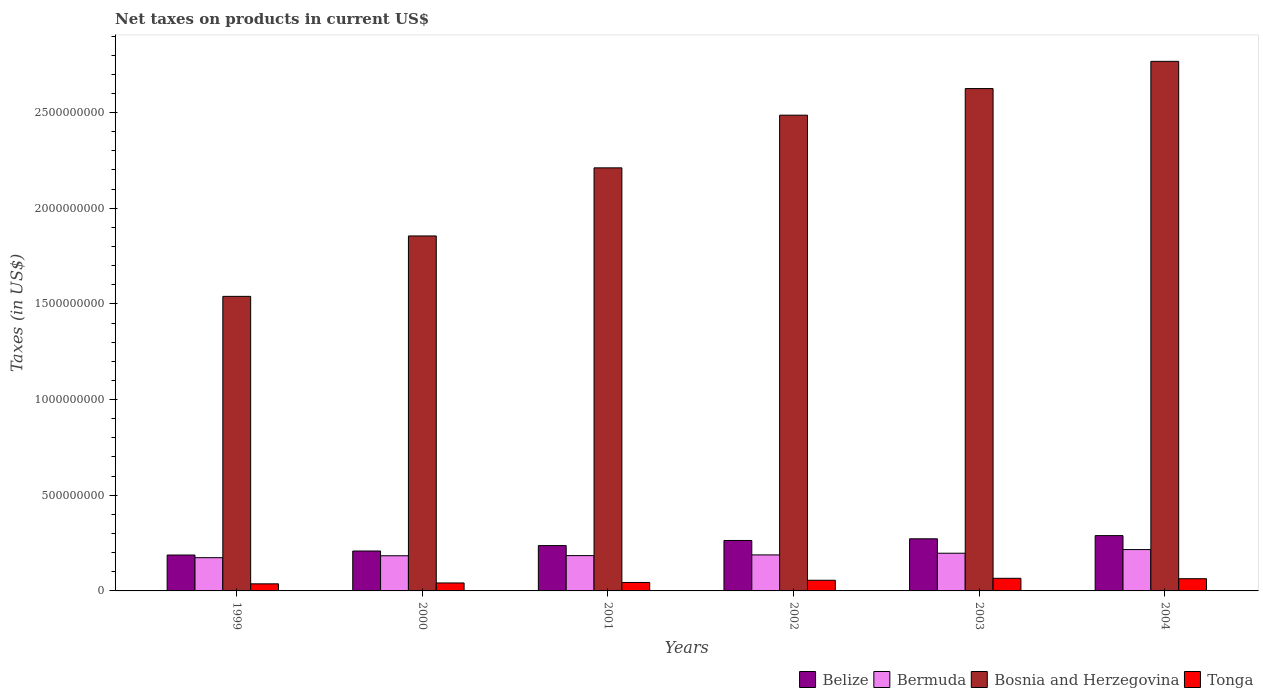How many different coloured bars are there?
Offer a very short reply. 4. How many bars are there on the 4th tick from the left?
Keep it short and to the point. 4. What is the label of the 6th group of bars from the left?
Provide a succinct answer. 2004. What is the net taxes on products in Tonga in 1999?
Keep it short and to the point. 3.70e+07. Across all years, what is the maximum net taxes on products in Bermuda?
Your answer should be compact. 2.16e+08. Across all years, what is the minimum net taxes on products in Bosnia and Herzegovina?
Offer a very short reply. 1.54e+09. In which year was the net taxes on products in Tonga maximum?
Offer a very short reply. 2003. What is the total net taxes on products in Belize in the graph?
Keep it short and to the point. 1.46e+09. What is the difference between the net taxes on products in Tonga in 2003 and that in 2004?
Keep it short and to the point. 2.12e+06. What is the difference between the net taxes on products in Bosnia and Herzegovina in 2000 and the net taxes on products in Tonga in 2004?
Make the answer very short. 1.79e+09. What is the average net taxes on products in Belize per year?
Offer a terse response. 2.43e+08. In the year 2000, what is the difference between the net taxes on products in Bosnia and Herzegovina and net taxes on products in Bermuda?
Your answer should be very brief. 1.67e+09. In how many years, is the net taxes on products in Bermuda greater than 700000000 US$?
Your answer should be very brief. 0. What is the ratio of the net taxes on products in Belize in 2001 to that in 2002?
Your answer should be compact. 0.9. Is the difference between the net taxes on products in Bosnia and Herzegovina in 2000 and 2004 greater than the difference between the net taxes on products in Bermuda in 2000 and 2004?
Keep it short and to the point. No. What is the difference between the highest and the second highest net taxes on products in Tonga?
Ensure brevity in your answer.  2.12e+06. What is the difference between the highest and the lowest net taxes on products in Bermuda?
Offer a terse response. 4.24e+07. Is it the case that in every year, the sum of the net taxes on products in Tonga and net taxes on products in Bosnia and Herzegovina is greater than the sum of net taxes on products in Belize and net taxes on products in Bermuda?
Your answer should be very brief. Yes. What does the 2nd bar from the left in 1999 represents?
Keep it short and to the point. Bermuda. What does the 3rd bar from the right in 1999 represents?
Provide a succinct answer. Bermuda. Is it the case that in every year, the sum of the net taxes on products in Bosnia and Herzegovina and net taxes on products in Belize is greater than the net taxes on products in Tonga?
Your response must be concise. Yes. How many years are there in the graph?
Keep it short and to the point. 6. Does the graph contain any zero values?
Provide a short and direct response. No. Where does the legend appear in the graph?
Give a very brief answer. Bottom right. How are the legend labels stacked?
Offer a very short reply. Horizontal. What is the title of the graph?
Your answer should be very brief. Net taxes on products in current US$. Does "Angola" appear as one of the legend labels in the graph?
Make the answer very short. No. What is the label or title of the Y-axis?
Your answer should be compact. Taxes (in US$). What is the Taxes (in US$) of Belize in 1999?
Ensure brevity in your answer.  1.88e+08. What is the Taxes (in US$) of Bermuda in 1999?
Provide a succinct answer. 1.74e+08. What is the Taxes (in US$) in Bosnia and Herzegovina in 1999?
Offer a terse response. 1.54e+09. What is the Taxes (in US$) in Tonga in 1999?
Keep it short and to the point. 3.70e+07. What is the Taxes (in US$) in Belize in 2000?
Provide a succinct answer. 2.09e+08. What is the Taxes (in US$) in Bermuda in 2000?
Your answer should be very brief. 1.84e+08. What is the Taxes (in US$) in Bosnia and Herzegovina in 2000?
Provide a succinct answer. 1.86e+09. What is the Taxes (in US$) of Tonga in 2000?
Give a very brief answer. 4.16e+07. What is the Taxes (in US$) of Belize in 2001?
Ensure brevity in your answer.  2.37e+08. What is the Taxes (in US$) in Bermuda in 2001?
Keep it short and to the point. 1.85e+08. What is the Taxes (in US$) of Bosnia and Herzegovina in 2001?
Offer a terse response. 2.21e+09. What is the Taxes (in US$) in Tonga in 2001?
Provide a short and direct response. 4.42e+07. What is the Taxes (in US$) of Belize in 2002?
Your response must be concise. 2.64e+08. What is the Taxes (in US$) in Bermuda in 2002?
Your response must be concise. 1.88e+08. What is the Taxes (in US$) in Bosnia and Herzegovina in 2002?
Keep it short and to the point. 2.49e+09. What is the Taxes (in US$) in Tonga in 2002?
Make the answer very short. 5.57e+07. What is the Taxes (in US$) in Belize in 2003?
Provide a short and direct response. 2.72e+08. What is the Taxes (in US$) of Bermuda in 2003?
Your response must be concise. 1.97e+08. What is the Taxes (in US$) in Bosnia and Herzegovina in 2003?
Offer a terse response. 2.63e+09. What is the Taxes (in US$) in Tonga in 2003?
Make the answer very short. 6.59e+07. What is the Taxes (in US$) in Belize in 2004?
Make the answer very short. 2.89e+08. What is the Taxes (in US$) in Bermuda in 2004?
Your response must be concise. 2.16e+08. What is the Taxes (in US$) in Bosnia and Herzegovina in 2004?
Offer a terse response. 2.77e+09. What is the Taxes (in US$) of Tonga in 2004?
Make the answer very short. 6.38e+07. Across all years, what is the maximum Taxes (in US$) in Belize?
Offer a very short reply. 2.89e+08. Across all years, what is the maximum Taxes (in US$) of Bermuda?
Your response must be concise. 2.16e+08. Across all years, what is the maximum Taxes (in US$) of Bosnia and Herzegovina?
Offer a terse response. 2.77e+09. Across all years, what is the maximum Taxes (in US$) of Tonga?
Offer a terse response. 6.59e+07. Across all years, what is the minimum Taxes (in US$) of Belize?
Ensure brevity in your answer.  1.88e+08. Across all years, what is the minimum Taxes (in US$) in Bermuda?
Your response must be concise. 1.74e+08. Across all years, what is the minimum Taxes (in US$) in Bosnia and Herzegovina?
Offer a terse response. 1.54e+09. Across all years, what is the minimum Taxes (in US$) of Tonga?
Give a very brief answer. 3.70e+07. What is the total Taxes (in US$) in Belize in the graph?
Make the answer very short. 1.46e+09. What is the total Taxes (in US$) in Bermuda in the graph?
Offer a terse response. 1.14e+09. What is the total Taxes (in US$) of Bosnia and Herzegovina in the graph?
Provide a succinct answer. 1.35e+1. What is the total Taxes (in US$) of Tonga in the graph?
Give a very brief answer. 3.08e+08. What is the difference between the Taxes (in US$) of Belize in 1999 and that in 2000?
Keep it short and to the point. -2.09e+07. What is the difference between the Taxes (in US$) of Bermuda in 1999 and that in 2000?
Your answer should be compact. -1.01e+07. What is the difference between the Taxes (in US$) in Bosnia and Herzegovina in 1999 and that in 2000?
Provide a short and direct response. -3.16e+08. What is the difference between the Taxes (in US$) in Tonga in 1999 and that in 2000?
Your answer should be very brief. -4.54e+06. What is the difference between the Taxes (in US$) of Belize in 1999 and that in 2001?
Provide a short and direct response. -4.93e+07. What is the difference between the Taxes (in US$) of Bermuda in 1999 and that in 2001?
Provide a short and direct response. -1.09e+07. What is the difference between the Taxes (in US$) in Bosnia and Herzegovina in 1999 and that in 2001?
Make the answer very short. -6.72e+08. What is the difference between the Taxes (in US$) of Tonga in 1999 and that in 2001?
Provide a short and direct response. -7.20e+06. What is the difference between the Taxes (in US$) in Belize in 1999 and that in 2002?
Your response must be concise. -7.60e+07. What is the difference between the Taxes (in US$) of Bermuda in 1999 and that in 2002?
Provide a succinct answer. -1.46e+07. What is the difference between the Taxes (in US$) of Bosnia and Herzegovina in 1999 and that in 2002?
Your response must be concise. -9.47e+08. What is the difference between the Taxes (in US$) in Tonga in 1999 and that in 2002?
Make the answer very short. -1.87e+07. What is the difference between the Taxes (in US$) of Belize in 1999 and that in 2003?
Your response must be concise. -8.48e+07. What is the difference between the Taxes (in US$) in Bermuda in 1999 and that in 2003?
Offer a very short reply. -2.33e+07. What is the difference between the Taxes (in US$) in Bosnia and Herzegovina in 1999 and that in 2003?
Keep it short and to the point. -1.09e+09. What is the difference between the Taxes (in US$) in Tonga in 1999 and that in 2003?
Give a very brief answer. -2.89e+07. What is the difference between the Taxes (in US$) of Belize in 1999 and that in 2004?
Offer a terse response. -1.01e+08. What is the difference between the Taxes (in US$) in Bermuda in 1999 and that in 2004?
Offer a terse response. -4.24e+07. What is the difference between the Taxes (in US$) in Bosnia and Herzegovina in 1999 and that in 2004?
Offer a very short reply. -1.23e+09. What is the difference between the Taxes (in US$) of Tonga in 1999 and that in 2004?
Your answer should be compact. -2.68e+07. What is the difference between the Taxes (in US$) of Belize in 2000 and that in 2001?
Your response must be concise. -2.83e+07. What is the difference between the Taxes (in US$) of Bermuda in 2000 and that in 2001?
Provide a short and direct response. -8.67e+05. What is the difference between the Taxes (in US$) of Bosnia and Herzegovina in 2000 and that in 2001?
Ensure brevity in your answer.  -3.56e+08. What is the difference between the Taxes (in US$) in Tonga in 2000 and that in 2001?
Ensure brevity in your answer.  -2.67e+06. What is the difference between the Taxes (in US$) in Belize in 2000 and that in 2002?
Offer a very short reply. -5.51e+07. What is the difference between the Taxes (in US$) in Bermuda in 2000 and that in 2002?
Your answer should be very brief. -4.49e+06. What is the difference between the Taxes (in US$) in Bosnia and Herzegovina in 2000 and that in 2002?
Provide a succinct answer. -6.31e+08. What is the difference between the Taxes (in US$) in Tonga in 2000 and that in 2002?
Make the answer very short. -1.42e+07. What is the difference between the Taxes (in US$) of Belize in 2000 and that in 2003?
Provide a short and direct response. -6.38e+07. What is the difference between the Taxes (in US$) of Bermuda in 2000 and that in 2003?
Your answer should be very brief. -1.32e+07. What is the difference between the Taxes (in US$) in Bosnia and Herzegovina in 2000 and that in 2003?
Provide a short and direct response. -7.70e+08. What is the difference between the Taxes (in US$) of Tonga in 2000 and that in 2003?
Your answer should be very brief. -2.43e+07. What is the difference between the Taxes (in US$) in Belize in 2000 and that in 2004?
Your response must be concise. -8.04e+07. What is the difference between the Taxes (in US$) of Bermuda in 2000 and that in 2004?
Your answer should be compact. -3.23e+07. What is the difference between the Taxes (in US$) of Bosnia and Herzegovina in 2000 and that in 2004?
Make the answer very short. -9.12e+08. What is the difference between the Taxes (in US$) in Tonga in 2000 and that in 2004?
Your answer should be very brief. -2.22e+07. What is the difference between the Taxes (in US$) of Belize in 2001 and that in 2002?
Provide a short and direct response. -2.67e+07. What is the difference between the Taxes (in US$) in Bermuda in 2001 and that in 2002?
Keep it short and to the point. -3.62e+06. What is the difference between the Taxes (in US$) of Bosnia and Herzegovina in 2001 and that in 2002?
Provide a succinct answer. -2.75e+08. What is the difference between the Taxes (in US$) in Tonga in 2001 and that in 2002?
Offer a very short reply. -1.15e+07. What is the difference between the Taxes (in US$) in Belize in 2001 and that in 2003?
Provide a succinct answer. -3.55e+07. What is the difference between the Taxes (in US$) in Bermuda in 2001 and that in 2003?
Give a very brief answer. -1.24e+07. What is the difference between the Taxes (in US$) in Bosnia and Herzegovina in 2001 and that in 2003?
Your response must be concise. -4.14e+08. What is the difference between the Taxes (in US$) of Tonga in 2001 and that in 2003?
Ensure brevity in your answer.  -2.17e+07. What is the difference between the Taxes (in US$) of Belize in 2001 and that in 2004?
Your answer should be very brief. -5.21e+07. What is the difference between the Taxes (in US$) of Bermuda in 2001 and that in 2004?
Give a very brief answer. -3.15e+07. What is the difference between the Taxes (in US$) of Bosnia and Herzegovina in 2001 and that in 2004?
Ensure brevity in your answer.  -5.57e+08. What is the difference between the Taxes (in US$) in Tonga in 2001 and that in 2004?
Ensure brevity in your answer.  -1.96e+07. What is the difference between the Taxes (in US$) of Belize in 2002 and that in 2003?
Your answer should be very brief. -8.74e+06. What is the difference between the Taxes (in US$) in Bermuda in 2002 and that in 2003?
Your answer should be compact. -8.75e+06. What is the difference between the Taxes (in US$) of Bosnia and Herzegovina in 2002 and that in 2003?
Provide a short and direct response. -1.39e+08. What is the difference between the Taxes (in US$) in Tonga in 2002 and that in 2003?
Your response must be concise. -1.02e+07. What is the difference between the Taxes (in US$) in Belize in 2002 and that in 2004?
Provide a succinct answer. -2.53e+07. What is the difference between the Taxes (in US$) of Bermuda in 2002 and that in 2004?
Ensure brevity in your answer.  -2.78e+07. What is the difference between the Taxes (in US$) in Bosnia and Herzegovina in 2002 and that in 2004?
Keep it short and to the point. -2.81e+08. What is the difference between the Taxes (in US$) in Tonga in 2002 and that in 2004?
Keep it short and to the point. -8.05e+06. What is the difference between the Taxes (in US$) in Belize in 2003 and that in 2004?
Provide a succinct answer. -1.66e+07. What is the difference between the Taxes (in US$) in Bermuda in 2003 and that in 2004?
Make the answer very short. -1.91e+07. What is the difference between the Taxes (in US$) of Bosnia and Herzegovina in 2003 and that in 2004?
Your answer should be compact. -1.42e+08. What is the difference between the Taxes (in US$) of Tonga in 2003 and that in 2004?
Your answer should be compact. 2.12e+06. What is the difference between the Taxes (in US$) of Belize in 1999 and the Taxes (in US$) of Bermuda in 2000?
Ensure brevity in your answer.  3.87e+06. What is the difference between the Taxes (in US$) in Belize in 1999 and the Taxes (in US$) in Bosnia and Herzegovina in 2000?
Your answer should be compact. -1.67e+09. What is the difference between the Taxes (in US$) in Belize in 1999 and the Taxes (in US$) in Tonga in 2000?
Provide a short and direct response. 1.46e+08. What is the difference between the Taxes (in US$) in Bermuda in 1999 and the Taxes (in US$) in Bosnia and Herzegovina in 2000?
Make the answer very short. -1.68e+09. What is the difference between the Taxes (in US$) in Bermuda in 1999 and the Taxes (in US$) in Tonga in 2000?
Keep it short and to the point. 1.32e+08. What is the difference between the Taxes (in US$) of Bosnia and Herzegovina in 1999 and the Taxes (in US$) of Tonga in 2000?
Provide a succinct answer. 1.50e+09. What is the difference between the Taxes (in US$) in Belize in 1999 and the Taxes (in US$) in Bermuda in 2001?
Give a very brief answer. 3.01e+06. What is the difference between the Taxes (in US$) of Belize in 1999 and the Taxes (in US$) of Bosnia and Herzegovina in 2001?
Provide a succinct answer. -2.02e+09. What is the difference between the Taxes (in US$) of Belize in 1999 and the Taxes (in US$) of Tonga in 2001?
Offer a very short reply. 1.43e+08. What is the difference between the Taxes (in US$) of Bermuda in 1999 and the Taxes (in US$) of Bosnia and Herzegovina in 2001?
Ensure brevity in your answer.  -2.04e+09. What is the difference between the Taxes (in US$) in Bermuda in 1999 and the Taxes (in US$) in Tonga in 2001?
Your answer should be very brief. 1.29e+08. What is the difference between the Taxes (in US$) in Bosnia and Herzegovina in 1999 and the Taxes (in US$) in Tonga in 2001?
Offer a very short reply. 1.50e+09. What is the difference between the Taxes (in US$) in Belize in 1999 and the Taxes (in US$) in Bermuda in 2002?
Offer a terse response. -6.15e+05. What is the difference between the Taxes (in US$) in Belize in 1999 and the Taxes (in US$) in Bosnia and Herzegovina in 2002?
Your answer should be compact. -2.30e+09. What is the difference between the Taxes (in US$) of Belize in 1999 and the Taxes (in US$) of Tonga in 2002?
Provide a short and direct response. 1.32e+08. What is the difference between the Taxes (in US$) in Bermuda in 1999 and the Taxes (in US$) in Bosnia and Herzegovina in 2002?
Your answer should be very brief. -2.31e+09. What is the difference between the Taxes (in US$) in Bermuda in 1999 and the Taxes (in US$) in Tonga in 2002?
Provide a succinct answer. 1.18e+08. What is the difference between the Taxes (in US$) in Bosnia and Herzegovina in 1999 and the Taxes (in US$) in Tonga in 2002?
Keep it short and to the point. 1.48e+09. What is the difference between the Taxes (in US$) in Belize in 1999 and the Taxes (in US$) in Bermuda in 2003?
Make the answer very short. -9.37e+06. What is the difference between the Taxes (in US$) in Belize in 1999 and the Taxes (in US$) in Bosnia and Herzegovina in 2003?
Keep it short and to the point. -2.44e+09. What is the difference between the Taxes (in US$) of Belize in 1999 and the Taxes (in US$) of Tonga in 2003?
Your response must be concise. 1.22e+08. What is the difference between the Taxes (in US$) in Bermuda in 1999 and the Taxes (in US$) in Bosnia and Herzegovina in 2003?
Provide a short and direct response. -2.45e+09. What is the difference between the Taxes (in US$) in Bermuda in 1999 and the Taxes (in US$) in Tonga in 2003?
Provide a short and direct response. 1.08e+08. What is the difference between the Taxes (in US$) of Bosnia and Herzegovina in 1999 and the Taxes (in US$) of Tonga in 2003?
Keep it short and to the point. 1.47e+09. What is the difference between the Taxes (in US$) of Belize in 1999 and the Taxes (in US$) of Bermuda in 2004?
Give a very brief answer. -2.84e+07. What is the difference between the Taxes (in US$) in Belize in 1999 and the Taxes (in US$) in Bosnia and Herzegovina in 2004?
Make the answer very short. -2.58e+09. What is the difference between the Taxes (in US$) in Belize in 1999 and the Taxes (in US$) in Tonga in 2004?
Offer a terse response. 1.24e+08. What is the difference between the Taxes (in US$) of Bermuda in 1999 and the Taxes (in US$) of Bosnia and Herzegovina in 2004?
Offer a terse response. -2.59e+09. What is the difference between the Taxes (in US$) in Bermuda in 1999 and the Taxes (in US$) in Tonga in 2004?
Give a very brief answer. 1.10e+08. What is the difference between the Taxes (in US$) in Bosnia and Herzegovina in 1999 and the Taxes (in US$) in Tonga in 2004?
Your response must be concise. 1.48e+09. What is the difference between the Taxes (in US$) in Belize in 2000 and the Taxes (in US$) in Bermuda in 2001?
Give a very brief answer. 2.40e+07. What is the difference between the Taxes (in US$) in Belize in 2000 and the Taxes (in US$) in Bosnia and Herzegovina in 2001?
Your response must be concise. -2.00e+09. What is the difference between the Taxes (in US$) of Belize in 2000 and the Taxes (in US$) of Tonga in 2001?
Offer a terse response. 1.64e+08. What is the difference between the Taxes (in US$) in Bermuda in 2000 and the Taxes (in US$) in Bosnia and Herzegovina in 2001?
Your answer should be compact. -2.03e+09. What is the difference between the Taxes (in US$) in Bermuda in 2000 and the Taxes (in US$) in Tonga in 2001?
Offer a terse response. 1.40e+08. What is the difference between the Taxes (in US$) of Bosnia and Herzegovina in 2000 and the Taxes (in US$) of Tonga in 2001?
Offer a terse response. 1.81e+09. What is the difference between the Taxes (in US$) in Belize in 2000 and the Taxes (in US$) in Bermuda in 2002?
Offer a terse response. 2.03e+07. What is the difference between the Taxes (in US$) of Belize in 2000 and the Taxes (in US$) of Bosnia and Herzegovina in 2002?
Your response must be concise. -2.28e+09. What is the difference between the Taxes (in US$) of Belize in 2000 and the Taxes (in US$) of Tonga in 2002?
Your response must be concise. 1.53e+08. What is the difference between the Taxes (in US$) of Bermuda in 2000 and the Taxes (in US$) of Bosnia and Herzegovina in 2002?
Make the answer very short. -2.30e+09. What is the difference between the Taxes (in US$) in Bermuda in 2000 and the Taxes (in US$) in Tonga in 2002?
Your answer should be very brief. 1.28e+08. What is the difference between the Taxes (in US$) of Bosnia and Herzegovina in 2000 and the Taxes (in US$) of Tonga in 2002?
Offer a very short reply. 1.80e+09. What is the difference between the Taxes (in US$) in Belize in 2000 and the Taxes (in US$) in Bermuda in 2003?
Make the answer very short. 1.16e+07. What is the difference between the Taxes (in US$) of Belize in 2000 and the Taxes (in US$) of Bosnia and Herzegovina in 2003?
Your answer should be very brief. -2.42e+09. What is the difference between the Taxes (in US$) in Belize in 2000 and the Taxes (in US$) in Tonga in 2003?
Your answer should be very brief. 1.43e+08. What is the difference between the Taxes (in US$) of Bermuda in 2000 and the Taxes (in US$) of Bosnia and Herzegovina in 2003?
Provide a succinct answer. -2.44e+09. What is the difference between the Taxes (in US$) in Bermuda in 2000 and the Taxes (in US$) in Tonga in 2003?
Give a very brief answer. 1.18e+08. What is the difference between the Taxes (in US$) of Bosnia and Herzegovina in 2000 and the Taxes (in US$) of Tonga in 2003?
Offer a terse response. 1.79e+09. What is the difference between the Taxes (in US$) in Belize in 2000 and the Taxes (in US$) in Bermuda in 2004?
Provide a short and direct response. -7.50e+06. What is the difference between the Taxes (in US$) of Belize in 2000 and the Taxes (in US$) of Bosnia and Herzegovina in 2004?
Ensure brevity in your answer.  -2.56e+09. What is the difference between the Taxes (in US$) in Belize in 2000 and the Taxes (in US$) in Tonga in 2004?
Make the answer very short. 1.45e+08. What is the difference between the Taxes (in US$) in Bermuda in 2000 and the Taxes (in US$) in Bosnia and Herzegovina in 2004?
Your answer should be very brief. -2.58e+09. What is the difference between the Taxes (in US$) of Bermuda in 2000 and the Taxes (in US$) of Tonga in 2004?
Your response must be concise. 1.20e+08. What is the difference between the Taxes (in US$) in Bosnia and Herzegovina in 2000 and the Taxes (in US$) in Tonga in 2004?
Keep it short and to the point. 1.79e+09. What is the difference between the Taxes (in US$) of Belize in 2001 and the Taxes (in US$) of Bermuda in 2002?
Offer a terse response. 4.87e+07. What is the difference between the Taxes (in US$) of Belize in 2001 and the Taxes (in US$) of Bosnia and Herzegovina in 2002?
Your response must be concise. -2.25e+09. What is the difference between the Taxes (in US$) of Belize in 2001 and the Taxes (in US$) of Tonga in 2002?
Provide a short and direct response. 1.81e+08. What is the difference between the Taxes (in US$) of Bermuda in 2001 and the Taxes (in US$) of Bosnia and Herzegovina in 2002?
Your response must be concise. -2.30e+09. What is the difference between the Taxes (in US$) of Bermuda in 2001 and the Taxes (in US$) of Tonga in 2002?
Ensure brevity in your answer.  1.29e+08. What is the difference between the Taxes (in US$) of Bosnia and Herzegovina in 2001 and the Taxes (in US$) of Tonga in 2002?
Keep it short and to the point. 2.16e+09. What is the difference between the Taxes (in US$) of Belize in 2001 and the Taxes (in US$) of Bermuda in 2003?
Provide a short and direct response. 3.99e+07. What is the difference between the Taxes (in US$) in Belize in 2001 and the Taxes (in US$) in Bosnia and Herzegovina in 2003?
Provide a short and direct response. -2.39e+09. What is the difference between the Taxes (in US$) of Belize in 2001 and the Taxes (in US$) of Tonga in 2003?
Keep it short and to the point. 1.71e+08. What is the difference between the Taxes (in US$) in Bermuda in 2001 and the Taxes (in US$) in Bosnia and Herzegovina in 2003?
Offer a very short reply. -2.44e+09. What is the difference between the Taxes (in US$) of Bermuda in 2001 and the Taxes (in US$) of Tonga in 2003?
Keep it short and to the point. 1.19e+08. What is the difference between the Taxes (in US$) in Bosnia and Herzegovina in 2001 and the Taxes (in US$) in Tonga in 2003?
Provide a succinct answer. 2.15e+09. What is the difference between the Taxes (in US$) of Belize in 2001 and the Taxes (in US$) of Bermuda in 2004?
Give a very brief answer. 2.08e+07. What is the difference between the Taxes (in US$) of Belize in 2001 and the Taxes (in US$) of Bosnia and Herzegovina in 2004?
Your answer should be very brief. -2.53e+09. What is the difference between the Taxes (in US$) in Belize in 2001 and the Taxes (in US$) in Tonga in 2004?
Offer a very short reply. 1.73e+08. What is the difference between the Taxes (in US$) in Bermuda in 2001 and the Taxes (in US$) in Bosnia and Herzegovina in 2004?
Offer a very short reply. -2.58e+09. What is the difference between the Taxes (in US$) of Bermuda in 2001 and the Taxes (in US$) of Tonga in 2004?
Offer a terse response. 1.21e+08. What is the difference between the Taxes (in US$) in Bosnia and Herzegovina in 2001 and the Taxes (in US$) in Tonga in 2004?
Your response must be concise. 2.15e+09. What is the difference between the Taxes (in US$) of Belize in 2002 and the Taxes (in US$) of Bermuda in 2003?
Keep it short and to the point. 6.67e+07. What is the difference between the Taxes (in US$) of Belize in 2002 and the Taxes (in US$) of Bosnia and Herzegovina in 2003?
Your response must be concise. -2.36e+09. What is the difference between the Taxes (in US$) of Belize in 2002 and the Taxes (in US$) of Tonga in 2003?
Ensure brevity in your answer.  1.98e+08. What is the difference between the Taxes (in US$) of Bermuda in 2002 and the Taxes (in US$) of Bosnia and Herzegovina in 2003?
Your answer should be compact. -2.44e+09. What is the difference between the Taxes (in US$) in Bermuda in 2002 and the Taxes (in US$) in Tonga in 2003?
Your answer should be compact. 1.22e+08. What is the difference between the Taxes (in US$) in Bosnia and Herzegovina in 2002 and the Taxes (in US$) in Tonga in 2003?
Your answer should be compact. 2.42e+09. What is the difference between the Taxes (in US$) of Belize in 2002 and the Taxes (in US$) of Bermuda in 2004?
Your answer should be very brief. 4.76e+07. What is the difference between the Taxes (in US$) in Belize in 2002 and the Taxes (in US$) in Bosnia and Herzegovina in 2004?
Your answer should be compact. -2.50e+09. What is the difference between the Taxes (in US$) of Belize in 2002 and the Taxes (in US$) of Tonga in 2004?
Your answer should be very brief. 2.00e+08. What is the difference between the Taxes (in US$) in Bermuda in 2002 and the Taxes (in US$) in Bosnia and Herzegovina in 2004?
Keep it short and to the point. -2.58e+09. What is the difference between the Taxes (in US$) in Bermuda in 2002 and the Taxes (in US$) in Tonga in 2004?
Give a very brief answer. 1.24e+08. What is the difference between the Taxes (in US$) of Bosnia and Herzegovina in 2002 and the Taxes (in US$) of Tonga in 2004?
Give a very brief answer. 2.42e+09. What is the difference between the Taxes (in US$) in Belize in 2003 and the Taxes (in US$) in Bermuda in 2004?
Make the answer very short. 5.63e+07. What is the difference between the Taxes (in US$) in Belize in 2003 and the Taxes (in US$) in Bosnia and Herzegovina in 2004?
Your answer should be very brief. -2.50e+09. What is the difference between the Taxes (in US$) in Belize in 2003 and the Taxes (in US$) in Tonga in 2004?
Keep it short and to the point. 2.09e+08. What is the difference between the Taxes (in US$) in Bermuda in 2003 and the Taxes (in US$) in Bosnia and Herzegovina in 2004?
Provide a short and direct response. -2.57e+09. What is the difference between the Taxes (in US$) in Bermuda in 2003 and the Taxes (in US$) in Tonga in 2004?
Your answer should be compact. 1.33e+08. What is the difference between the Taxes (in US$) of Bosnia and Herzegovina in 2003 and the Taxes (in US$) of Tonga in 2004?
Provide a succinct answer. 2.56e+09. What is the average Taxes (in US$) of Belize per year?
Offer a very short reply. 2.43e+08. What is the average Taxes (in US$) in Bermuda per year?
Your response must be concise. 1.91e+08. What is the average Taxes (in US$) in Bosnia and Herzegovina per year?
Offer a very short reply. 2.25e+09. What is the average Taxes (in US$) in Tonga per year?
Give a very brief answer. 5.14e+07. In the year 1999, what is the difference between the Taxes (in US$) of Belize and Taxes (in US$) of Bermuda?
Provide a short and direct response. 1.39e+07. In the year 1999, what is the difference between the Taxes (in US$) in Belize and Taxes (in US$) in Bosnia and Herzegovina?
Your response must be concise. -1.35e+09. In the year 1999, what is the difference between the Taxes (in US$) in Belize and Taxes (in US$) in Tonga?
Provide a succinct answer. 1.51e+08. In the year 1999, what is the difference between the Taxes (in US$) of Bermuda and Taxes (in US$) of Bosnia and Herzegovina?
Offer a terse response. -1.37e+09. In the year 1999, what is the difference between the Taxes (in US$) of Bermuda and Taxes (in US$) of Tonga?
Make the answer very short. 1.37e+08. In the year 1999, what is the difference between the Taxes (in US$) in Bosnia and Herzegovina and Taxes (in US$) in Tonga?
Ensure brevity in your answer.  1.50e+09. In the year 2000, what is the difference between the Taxes (in US$) of Belize and Taxes (in US$) of Bermuda?
Provide a short and direct response. 2.48e+07. In the year 2000, what is the difference between the Taxes (in US$) of Belize and Taxes (in US$) of Bosnia and Herzegovina?
Keep it short and to the point. -1.65e+09. In the year 2000, what is the difference between the Taxes (in US$) of Belize and Taxes (in US$) of Tonga?
Your response must be concise. 1.67e+08. In the year 2000, what is the difference between the Taxes (in US$) in Bermuda and Taxes (in US$) in Bosnia and Herzegovina?
Provide a short and direct response. -1.67e+09. In the year 2000, what is the difference between the Taxes (in US$) in Bermuda and Taxes (in US$) in Tonga?
Give a very brief answer. 1.42e+08. In the year 2000, what is the difference between the Taxes (in US$) in Bosnia and Herzegovina and Taxes (in US$) in Tonga?
Ensure brevity in your answer.  1.81e+09. In the year 2001, what is the difference between the Taxes (in US$) in Belize and Taxes (in US$) in Bermuda?
Offer a terse response. 5.23e+07. In the year 2001, what is the difference between the Taxes (in US$) of Belize and Taxes (in US$) of Bosnia and Herzegovina?
Make the answer very short. -1.97e+09. In the year 2001, what is the difference between the Taxes (in US$) of Belize and Taxes (in US$) of Tonga?
Make the answer very short. 1.93e+08. In the year 2001, what is the difference between the Taxes (in US$) in Bermuda and Taxes (in US$) in Bosnia and Herzegovina?
Your answer should be very brief. -2.03e+09. In the year 2001, what is the difference between the Taxes (in US$) of Bermuda and Taxes (in US$) of Tonga?
Provide a succinct answer. 1.40e+08. In the year 2001, what is the difference between the Taxes (in US$) in Bosnia and Herzegovina and Taxes (in US$) in Tonga?
Ensure brevity in your answer.  2.17e+09. In the year 2002, what is the difference between the Taxes (in US$) of Belize and Taxes (in US$) of Bermuda?
Provide a succinct answer. 7.54e+07. In the year 2002, what is the difference between the Taxes (in US$) of Belize and Taxes (in US$) of Bosnia and Herzegovina?
Your answer should be very brief. -2.22e+09. In the year 2002, what is the difference between the Taxes (in US$) in Belize and Taxes (in US$) in Tonga?
Offer a very short reply. 2.08e+08. In the year 2002, what is the difference between the Taxes (in US$) in Bermuda and Taxes (in US$) in Bosnia and Herzegovina?
Ensure brevity in your answer.  -2.30e+09. In the year 2002, what is the difference between the Taxes (in US$) of Bermuda and Taxes (in US$) of Tonga?
Ensure brevity in your answer.  1.32e+08. In the year 2002, what is the difference between the Taxes (in US$) in Bosnia and Herzegovina and Taxes (in US$) in Tonga?
Ensure brevity in your answer.  2.43e+09. In the year 2003, what is the difference between the Taxes (in US$) in Belize and Taxes (in US$) in Bermuda?
Your answer should be compact. 7.54e+07. In the year 2003, what is the difference between the Taxes (in US$) in Belize and Taxes (in US$) in Bosnia and Herzegovina?
Offer a very short reply. -2.35e+09. In the year 2003, what is the difference between the Taxes (in US$) of Belize and Taxes (in US$) of Tonga?
Your answer should be very brief. 2.06e+08. In the year 2003, what is the difference between the Taxes (in US$) of Bermuda and Taxes (in US$) of Bosnia and Herzegovina?
Ensure brevity in your answer.  -2.43e+09. In the year 2003, what is the difference between the Taxes (in US$) in Bermuda and Taxes (in US$) in Tonga?
Your answer should be compact. 1.31e+08. In the year 2003, what is the difference between the Taxes (in US$) in Bosnia and Herzegovina and Taxes (in US$) in Tonga?
Offer a very short reply. 2.56e+09. In the year 2004, what is the difference between the Taxes (in US$) in Belize and Taxes (in US$) in Bermuda?
Provide a short and direct response. 7.29e+07. In the year 2004, what is the difference between the Taxes (in US$) of Belize and Taxes (in US$) of Bosnia and Herzegovina?
Ensure brevity in your answer.  -2.48e+09. In the year 2004, what is the difference between the Taxes (in US$) of Belize and Taxes (in US$) of Tonga?
Give a very brief answer. 2.25e+08. In the year 2004, what is the difference between the Taxes (in US$) in Bermuda and Taxes (in US$) in Bosnia and Herzegovina?
Ensure brevity in your answer.  -2.55e+09. In the year 2004, what is the difference between the Taxes (in US$) in Bermuda and Taxes (in US$) in Tonga?
Make the answer very short. 1.52e+08. In the year 2004, what is the difference between the Taxes (in US$) of Bosnia and Herzegovina and Taxes (in US$) of Tonga?
Offer a very short reply. 2.70e+09. What is the ratio of the Taxes (in US$) in Belize in 1999 to that in 2000?
Provide a succinct answer. 0.9. What is the ratio of the Taxes (in US$) of Bermuda in 1999 to that in 2000?
Keep it short and to the point. 0.95. What is the ratio of the Taxes (in US$) in Bosnia and Herzegovina in 1999 to that in 2000?
Your answer should be very brief. 0.83. What is the ratio of the Taxes (in US$) of Tonga in 1999 to that in 2000?
Provide a short and direct response. 0.89. What is the ratio of the Taxes (in US$) of Belize in 1999 to that in 2001?
Keep it short and to the point. 0.79. What is the ratio of the Taxes (in US$) in Bermuda in 1999 to that in 2001?
Your answer should be very brief. 0.94. What is the ratio of the Taxes (in US$) of Bosnia and Herzegovina in 1999 to that in 2001?
Your response must be concise. 0.7. What is the ratio of the Taxes (in US$) in Tonga in 1999 to that in 2001?
Keep it short and to the point. 0.84. What is the ratio of the Taxes (in US$) in Belize in 1999 to that in 2002?
Your answer should be very brief. 0.71. What is the ratio of the Taxes (in US$) in Bermuda in 1999 to that in 2002?
Provide a succinct answer. 0.92. What is the ratio of the Taxes (in US$) in Bosnia and Herzegovina in 1999 to that in 2002?
Offer a very short reply. 0.62. What is the ratio of the Taxes (in US$) in Tonga in 1999 to that in 2002?
Keep it short and to the point. 0.66. What is the ratio of the Taxes (in US$) in Belize in 1999 to that in 2003?
Offer a very short reply. 0.69. What is the ratio of the Taxes (in US$) in Bermuda in 1999 to that in 2003?
Make the answer very short. 0.88. What is the ratio of the Taxes (in US$) of Bosnia and Herzegovina in 1999 to that in 2003?
Ensure brevity in your answer.  0.59. What is the ratio of the Taxes (in US$) in Tonga in 1999 to that in 2003?
Make the answer very short. 0.56. What is the ratio of the Taxes (in US$) in Belize in 1999 to that in 2004?
Offer a very short reply. 0.65. What is the ratio of the Taxes (in US$) in Bermuda in 1999 to that in 2004?
Ensure brevity in your answer.  0.8. What is the ratio of the Taxes (in US$) of Bosnia and Herzegovina in 1999 to that in 2004?
Your response must be concise. 0.56. What is the ratio of the Taxes (in US$) of Tonga in 1999 to that in 2004?
Give a very brief answer. 0.58. What is the ratio of the Taxes (in US$) of Belize in 2000 to that in 2001?
Provide a short and direct response. 0.88. What is the ratio of the Taxes (in US$) in Bosnia and Herzegovina in 2000 to that in 2001?
Offer a terse response. 0.84. What is the ratio of the Taxes (in US$) in Tonga in 2000 to that in 2001?
Provide a succinct answer. 0.94. What is the ratio of the Taxes (in US$) in Belize in 2000 to that in 2002?
Your response must be concise. 0.79. What is the ratio of the Taxes (in US$) in Bermuda in 2000 to that in 2002?
Ensure brevity in your answer.  0.98. What is the ratio of the Taxes (in US$) in Bosnia and Herzegovina in 2000 to that in 2002?
Provide a short and direct response. 0.75. What is the ratio of the Taxes (in US$) in Tonga in 2000 to that in 2002?
Make the answer very short. 0.75. What is the ratio of the Taxes (in US$) of Belize in 2000 to that in 2003?
Your answer should be compact. 0.77. What is the ratio of the Taxes (in US$) of Bermuda in 2000 to that in 2003?
Provide a short and direct response. 0.93. What is the ratio of the Taxes (in US$) in Bosnia and Herzegovina in 2000 to that in 2003?
Offer a terse response. 0.71. What is the ratio of the Taxes (in US$) in Tonga in 2000 to that in 2003?
Offer a very short reply. 0.63. What is the ratio of the Taxes (in US$) in Belize in 2000 to that in 2004?
Provide a short and direct response. 0.72. What is the ratio of the Taxes (in US$) of Bermuda in 2000 to that in 2004?
Your answer should be compact. 0.85. What is the ratio of the Taxes (in US$) of Bosnia and Herzegovina in 2000 to that in 2004?
Offer a terse response. 0.67. What is the ratio of the Taxes (in US$) of Tonga in 2000 to that in 2004?
Your answer should be very brief. 0.65. What is the ratio of the Taxes (in US$) of Belize in 2001 to that in 2002?
Your response must be concise. 0.9. What is the ratio of the Taxes (in US$) in Bermuda in 2001 to that in 2002?
Ensure brevity in your answer.  0.98. What is the ratio of the Taxes (in US$) of Bosnia and Herzegovina in 2001 to that in 2002?
Your response must be concise. 0.89. What is the ratio of the Taxes (in US$) in Tonga in 2001 to that in 2002?
Your answer should be compact. 0.79. What is the ratio of the Taxes (in US$) in Belize in 2001 to that in 2003?
Your answer should be very brief. 0.87. What is the ratio of the Taxes (in US$) in Bermuda in 2001 to that in 2003?
Offer a very short reply. 0.94. What is the ratio of the Taxes (in US$) in Bosnia and Herzegovina in 2001 to that in 2003?
Make the answer very short. 0.84. What is the ratio of the Taxes (in US$) in Tonga in 2001 to that in 2003?
Your answer should be very brief. 0.67. What is the ratio of the Taxes (in US$) of Belize in 2001 to that in 2004?
Give a very brief answer. 0.82. What is the ratio of the Taxes (in US$) of Bermuda in 2001 to that in 2004?
Ensure brevity in your answer.  0.85. What is the ratio of the Taxes (in US$) of Bosnia and Herzegovina in 2001 to that in 2004?
Your answer should be compact. 0.8. What is the ratio of the Taxes (in US$) of Tonga in 2001 to that in 2004?
Offer a terse response. 0.69. What is the ratio of the Taxes (in US$) of Belize in 2002 to that in 2003?
Ensure brevity in your answer.  0.97. What is the ratio of the Taxes (in US$) of Bermuda in 2002 to that in 2003?
Keep it short and to the point. 0.96. What is the ratio of the Taxes (in US$) in Bosnia and Herzegovina in 2002 to that in 2003?
Give a very brief answer. 0.95. What is the ratio of the Taxes (in US$) of Tonga in 2002 to that in 2003?
Offer a very short reply. 0.85. What is the ratio of the Taxes (in US$) in Belize in 2002 to that in 2004?
Ensure brevity in your answer.  0.91. What is the ratio of the Taxes (in US$) in Bermuda in 2002 to that in 2004?
Offer a very short reply. 0.87. What is the ratio of the Taxes (in US$) in Bosnia and Herzegovina in 2002 to that in 2004?
Make the answer very short. 0.9. What is the ratio of the Taxes (in US$) of Tonga in 2002 to that in 2004?
Your answer should be compact. 0.87. What is the ratio of the Taxes (in US$) in Belize in 2003 to that in 2004?
Your answer should be compact. 0.94. What is the ratio of the Taxes (in US$) of Bermuda in 2003 to that in 2004?
Provide a succinct answer. 0.91. What is the ratio of the Taxes (in US$) of Bosnia and Herzegovina in 2003 to that in 2004?
Provide a succinct answer. 0.95. What is the difference between the highest and the second highest Taxes (in US$) in Belize?
Your answer should be very brief. 1.66e+07. What is the difference between the highest and the second highest Taxes (in US$) in Bermuda?
Your answer should be compact. 1.91e+07. What is the difference between the highest and the second highest Taxes (in US$) in Bosnia and Herzegovina?
Keep it short and to the point. 1.42e+08. What is the difference between the highest and the second highest Taxes (in US$) in Tonga?
Offer a terse response. 2.12e+06. What is the difference between the highest and the lowest Taxes (in US$) in Belize?
Your answer should be compact. 1.01e+08. What is the difference between the highest and the lowest Taxes (in US$) of Bermuda?
Provide a succinct answer. 4.24e+07. What is the difference between the highest and the lowest Taxes (in US$) in Bosnia and Herzegovina?
Offer a very short reply. 1.23e+09. What is the difference between the highest and the lowest Taxes (in US$) in Tonga?
Your answer should be compact. 2.89e+07. 